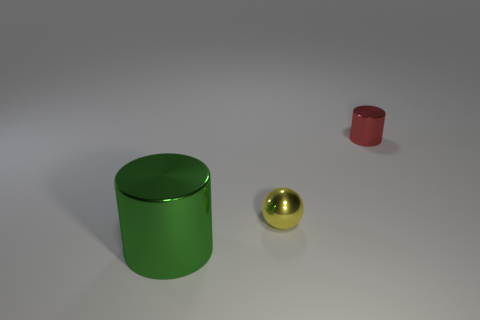Add 1 big cyan rubber spheres. How many objects exist? 4 Subtract all cylinders. How many objects are left? 1 Add 1 big cylinders. How many big cylinders are left? 2 Add 1 tiny red shiny cylinders. How many tiny red shiny cylinders exist? 2 Subtract 0 cyan cubes. How many objects are left? 3 Subtract all small red metal things. Subtract all green metallic objects. How many objects are left? 1 